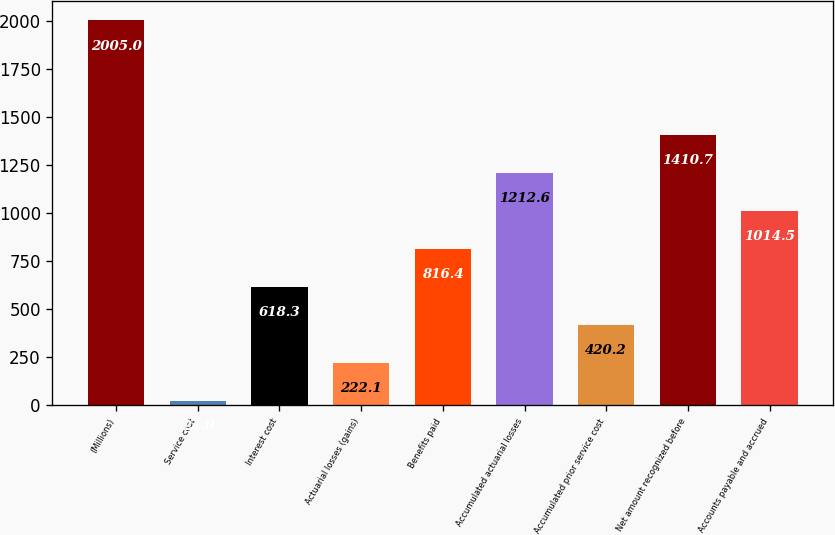Convert chart to OTSL. <chart><loc_0><loc_0><loc_500><loc_500><bar_chart><fcel>(Millions)<fcel>Service cost<fcel>Interest cost<fcel>Actuarial losses (gains)<fcel>Benefits paid<fcel>Accumulated actuarial losses<fcel>Accumulated prior service cost<fcel>Net amount recognized before<fcel>Accounts payable and accrued<nl><fcel>2005<fcel>24<fcel>618.3<fcel>222.1<fcel>816.4<fcel>1212.6<fcel>420.2<fcel>1410.7<fcel>1014.5<nl></chart> 